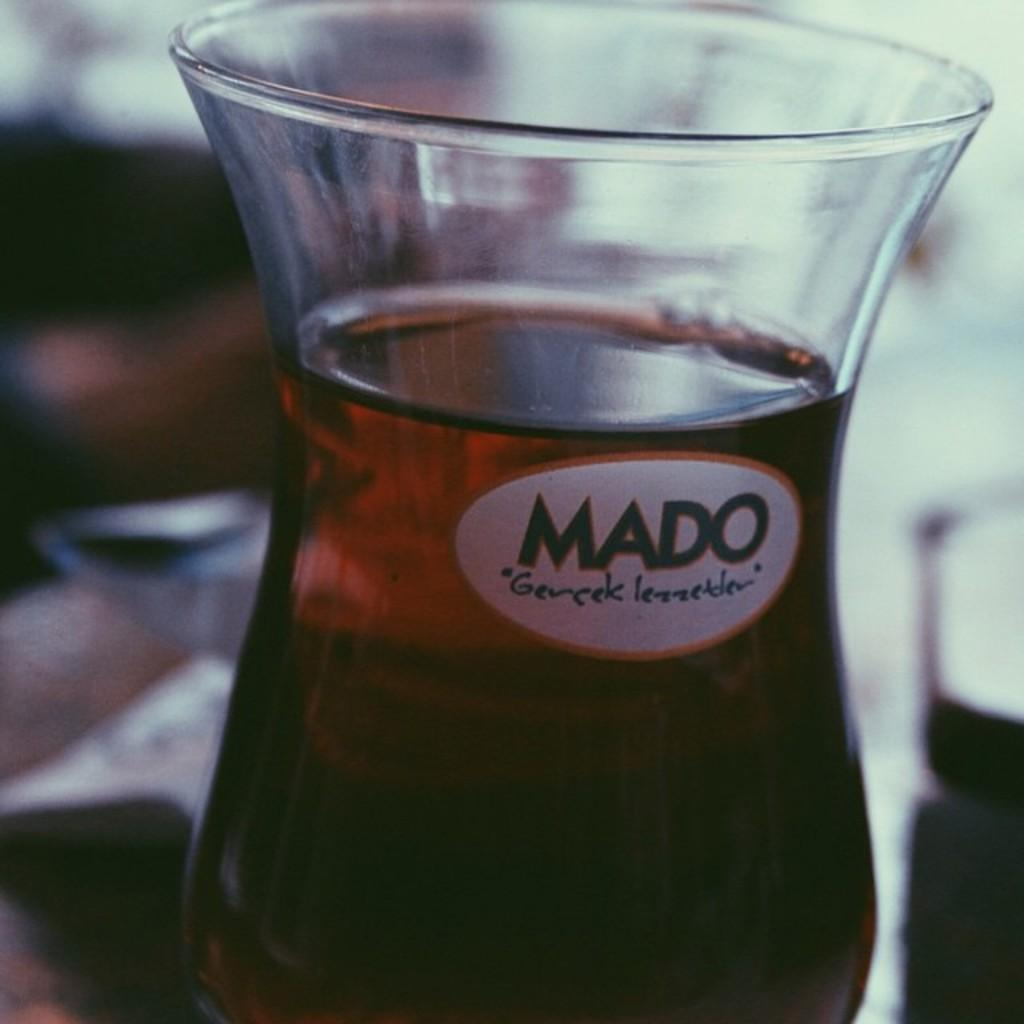Provide a one-sentence caption for the provided image. A dark drink inside a hurricane shaped glass that has a MADO logo. 